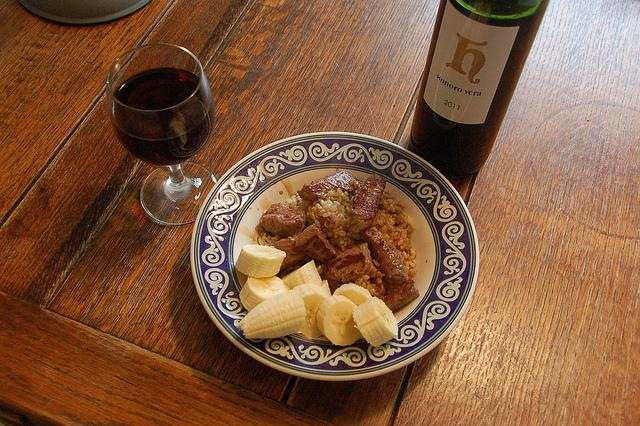Which item contains a lot of potassium?

Choices:
A) rice
B) banana
C) meat
D) wine banana 